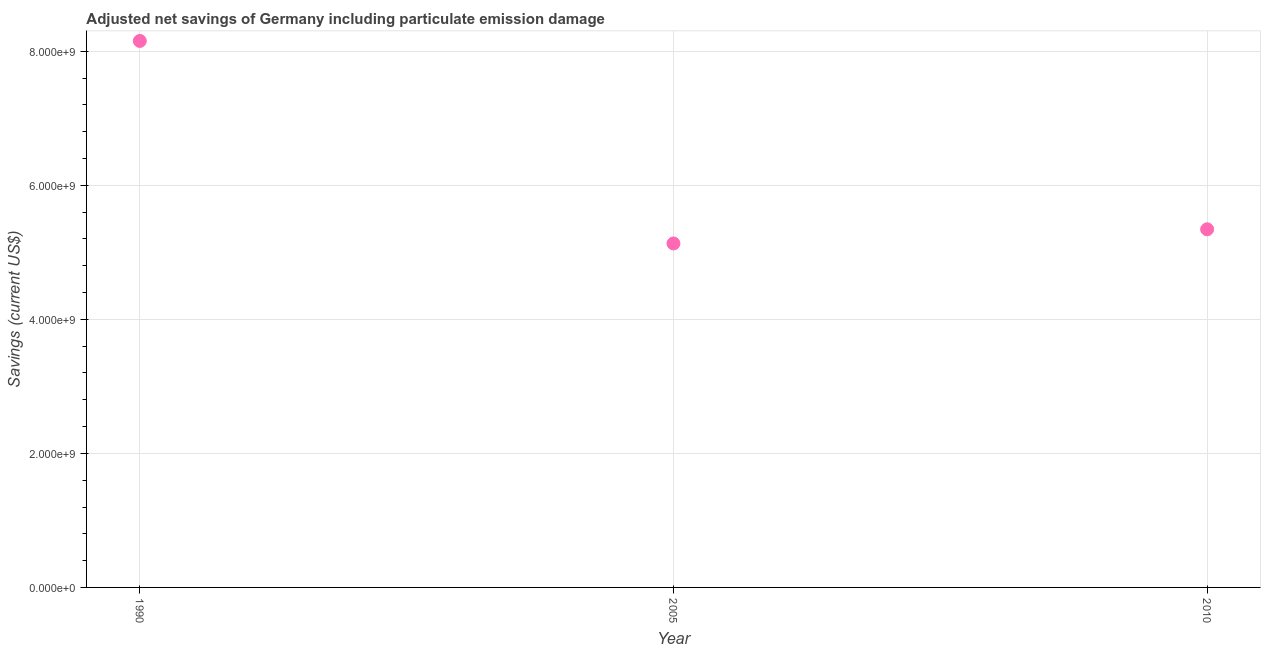What is the adjusted net savings in 1990?
Keep it short and to the point. 8.15e+09. Across all years, what is the maximum adjusted net savings?
Provide a short and direct response. 8.15e+09. Across all years, what is the minimum adjusted net savings?
Your answer should be very brief. 5.13e+09. In which year was the adjusted net savings maximum?
Your answer should be very brief. 1990. What is the sum of the adjusted net savings?
Your answer should be very brief. 1.86e+1. What is the difference between the adjusted net savings in 1990 and 2005?
Ensure brevity in your answer.  3.02e+09. What is the average adjusted net savings per year?
Make the answer very short. 6.21e+09. What is the median adjusted net savings?
Provide a succinct answer. 5.34e+09. What is the ratio of the adjusted net savings in 1990 to that in 2010?
Offer a terse response. 1.53. Is the adjusted net savings in 2005 less than that in 2010?
Your response must be concise. Yes. Is the difference between the adjusted net savings in 2005 and 2010 greater than the difference between any two years?
Give a very brief answer. No. What is the difference between the highest and the second highest adjusted net savings?
Make the answer very short. 2.81e+09. What is the difference between the highest and the lowest adjusted net savings?
Provide a succinct answer. 3.02e+09. In how many years, is the adjusted net savings greater than the average adjusted net savings taken over all years?
Offer a terse response. 1. Does the adjusted net savings monotonically increase over the years?
Your answer should be very brief. No. How many dotlines are there?
Give a very brief answer. 1. How many years are there in the graph?
Provide a short and direct response. 3. What is the difference between two consecutive major ticks on the Y-axis?
Ensure brevity in your answer.  2.00e+09. Are the values on the major ticks of Y-axis written in scientific E-notation?
Your response must be concise. Yes. Does the graph contain any zero values?
Offer a terse response. No. Does the graph contain grids?
Your response must be concise. Yes. What is the title of the graph?
Offer a terse response. Adjusted net savings of Germany including particulate emission damage. What is the label or title of the Y-axis?
Your response must be concise. Savings (current US$). What is the Savings (current US$) in 1990?
Your answer should be very brief. 8.15e+09. What is the Savings (current US$) in 2005?
Your response must be concise. 5.13e+09. What is the Savings (current US$) in 2010?
Your answer should be compact. 5.34e+09. What is the difference between the Savings (current US$) in 1990 and 2005?
Offer a terse response. 3.02e+09. What is the difference between the Savings (current US$) in 1990 and 2010?
Ensure brevity in your answer.  2.81e+09. What is the difference between the Savings (current US$) in 2005 and 2010?
Make the answer very short. -2.11e+08. What is the ratio of the Savings (current US$) in 1990 to that in 2005?
Ensure brevity in your answer.  1.59. What is the ratio of the Savings (current US$) in 1990 to that in 2010?
Your answer should be compact. 1.53. 